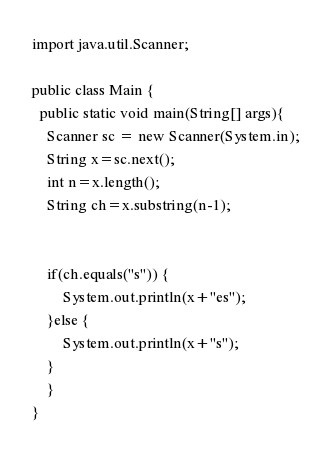Convert code to text. <code><loc_0><loc_0><loc_500><loc_500><_Java_>import java.util.Scanner;
 
public class Main {
  public static void main(String[] args){
    Scanner sc = new Scanner(System.in);
    String x=sc.next();
    int n=x.length();
    String ch=x.substring(n-1);
    
    		
    if(ch.equals("s")) {
    	System.out.println(x+"es");
    }else {
    	System.out.println(x+"s");
    }
    }
}</code> 